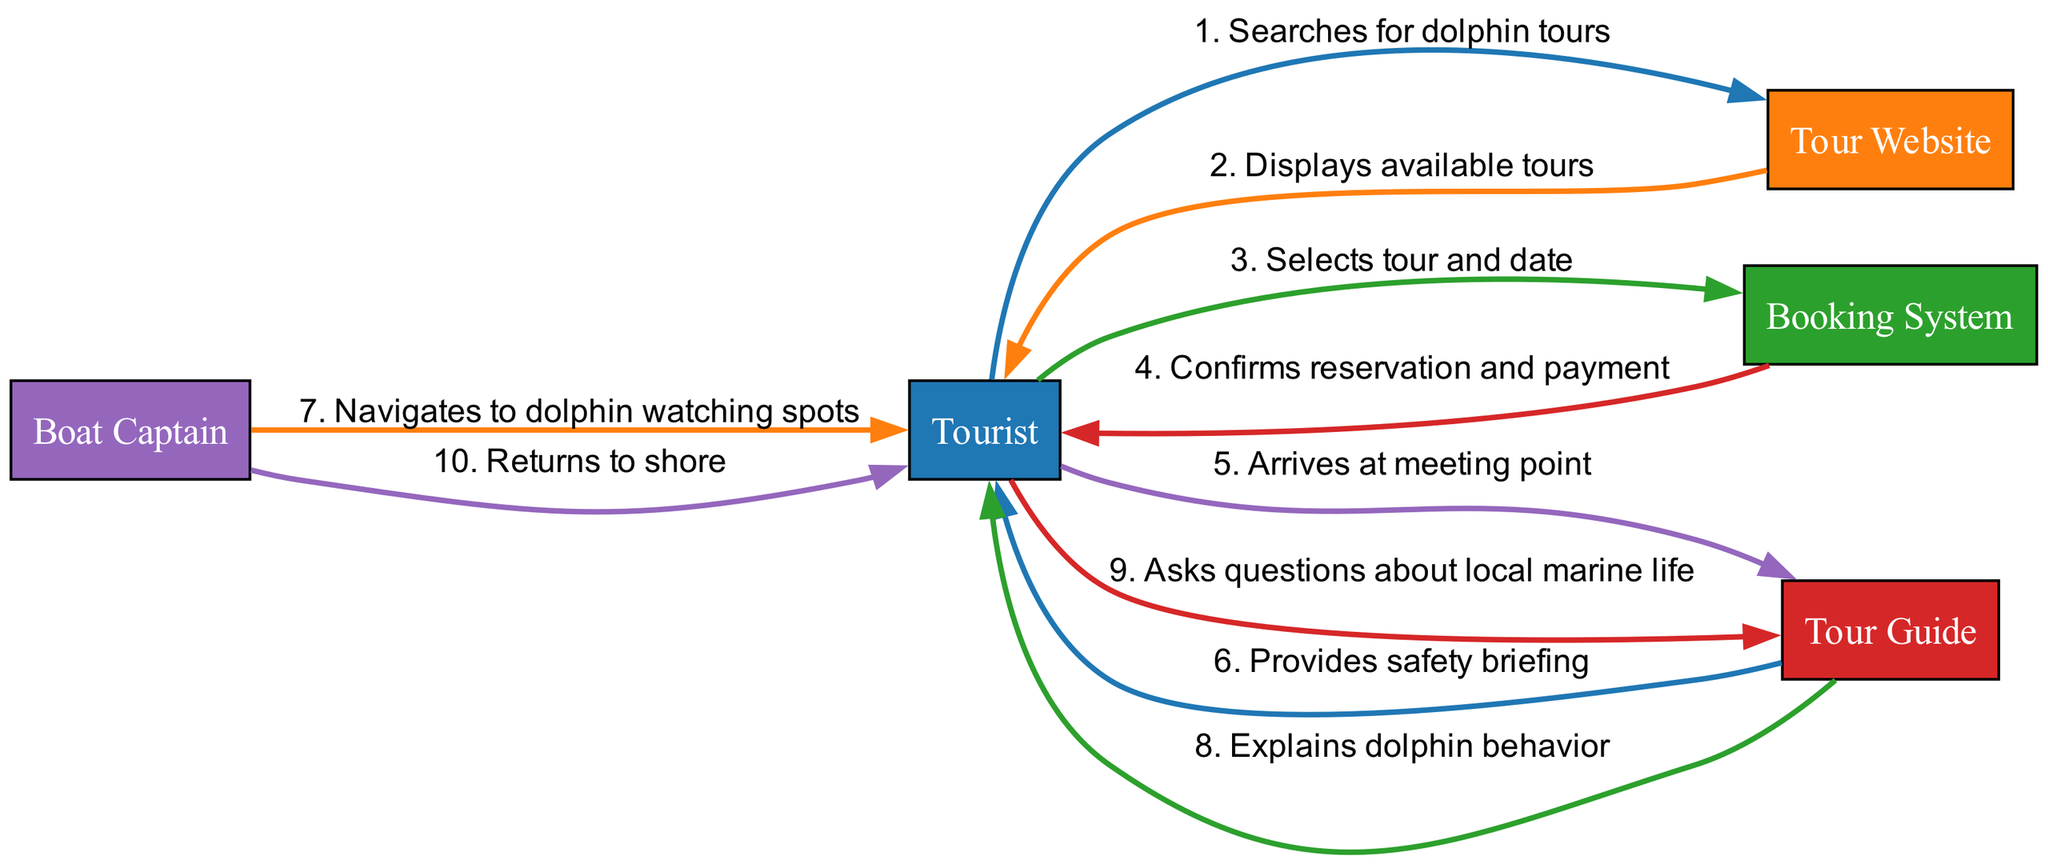What is the first action in the sequence? The diagram shows that the first action comes from the Tourist to the Tour Website, where the Tourist searches for dolphin tours.
Answer: Searches for dolphin tours How many actors are present in the diagram? The diagram lists five distinct actors: Tourist, Tour Website, Booking System, Tour Guide, and Boat Captain.
Answer: Five What action does the Tour Guide perform after the Tourist arrives at the meeting point? According to the flow, after the Tourist arrives, the Tour Guide provides a safety briefing.
Answer: Provides safety briefing Which actor returns the Tourist to shore? The diagram indicates that the Boat Captain is responsible for returning the Tourist to shore.
Answer: Boat Captain What action follows the confirmation of reservation and payment? After the Booking System confirms the reservation and payment, the next step is for the Tourist to arrive at the meeting point.
Answer: Arrives at meeting point What is the total number of actions displayed in the sequence? By counting all the edges connecting actions, we find there are ten distinct actions in the sequence.
Answer: Ten Which actor explains dolphin behavior to the Tourist? The Tour Guide is the actor who explains dolphin behavior to the Tourist, as per the sequence.
Answer: Tour Guide What question does the Tourist ask the Tour Guide? The Tourist, after receiving explanations, asks questions about local marine life.
Answer: Asks questions about local marine life Describe the flow of actions starting from the Tourist searching for dolphin tours to the return to shore. The Tourist first searches for dolphin tours, views available options, selects a tour, and makes a payment. Next, the Tourist arrives at the meeting point where the Tour Guide gives a safety briefing. Afterward, the Boat Captain navigates to dolphin watching spots, while the Tour Guide explains dolphin behavior. Finally, after the experience, the Boat Captain returns the Tourist to shore.
Answer: Tourist searches → Tour Website displays tours → Tourist selects tour and date → Booking System confirms → Tourist arrives → Tour Guide provides briefing → Boat Captain navigates → Tour Guide explains → Tourist asks questions → Boat Captain returns to shore 